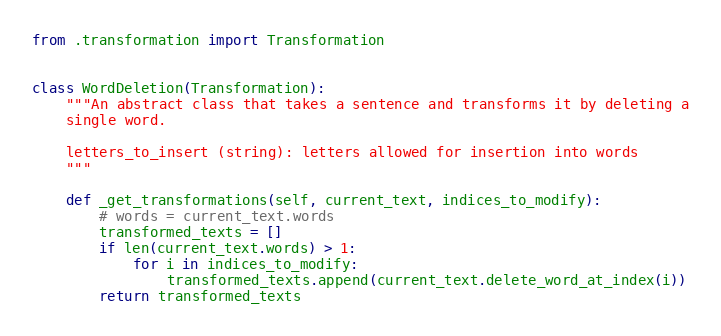<code> <loc_0><loc_0><loc_500><loc_500><_Python_>from .transformation import Transformation


class WordDeletion(Transformation):
    """An abstract class that takes a sentence and transforms it by deleting a
    single word.

    letters_to_insert (string): letters allowed for insertion into words
    """

    def _get_transformations(self, current_text, indices_to_modify):
        # words = current_text.words
        transformed_texts = []
        if len(current_text.words) > 1:
            for i in indices_to_modify:
                transformed_texts.append(current_text.delete_word_at_index(i))
        return transformed_texts
</code> 